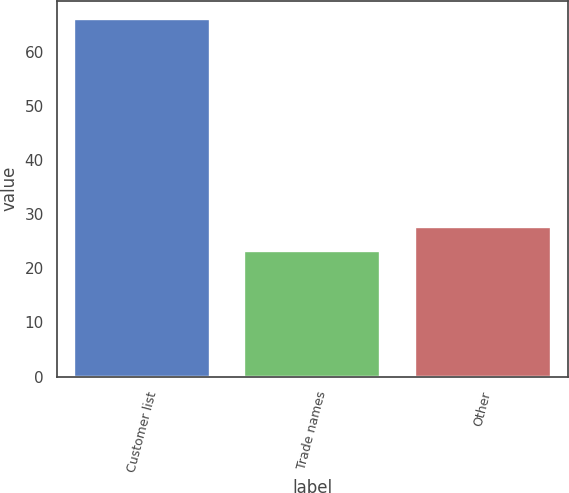Convert chart to OTSL. <chart><loc_0><loc_0><loc_500><loc_500><bar_chart><fcel>Customer list<fcel>Trade names<fcel>Other<nl><fcel>66.2<fcel>23.3<fcel>27.59<nl></chart> 